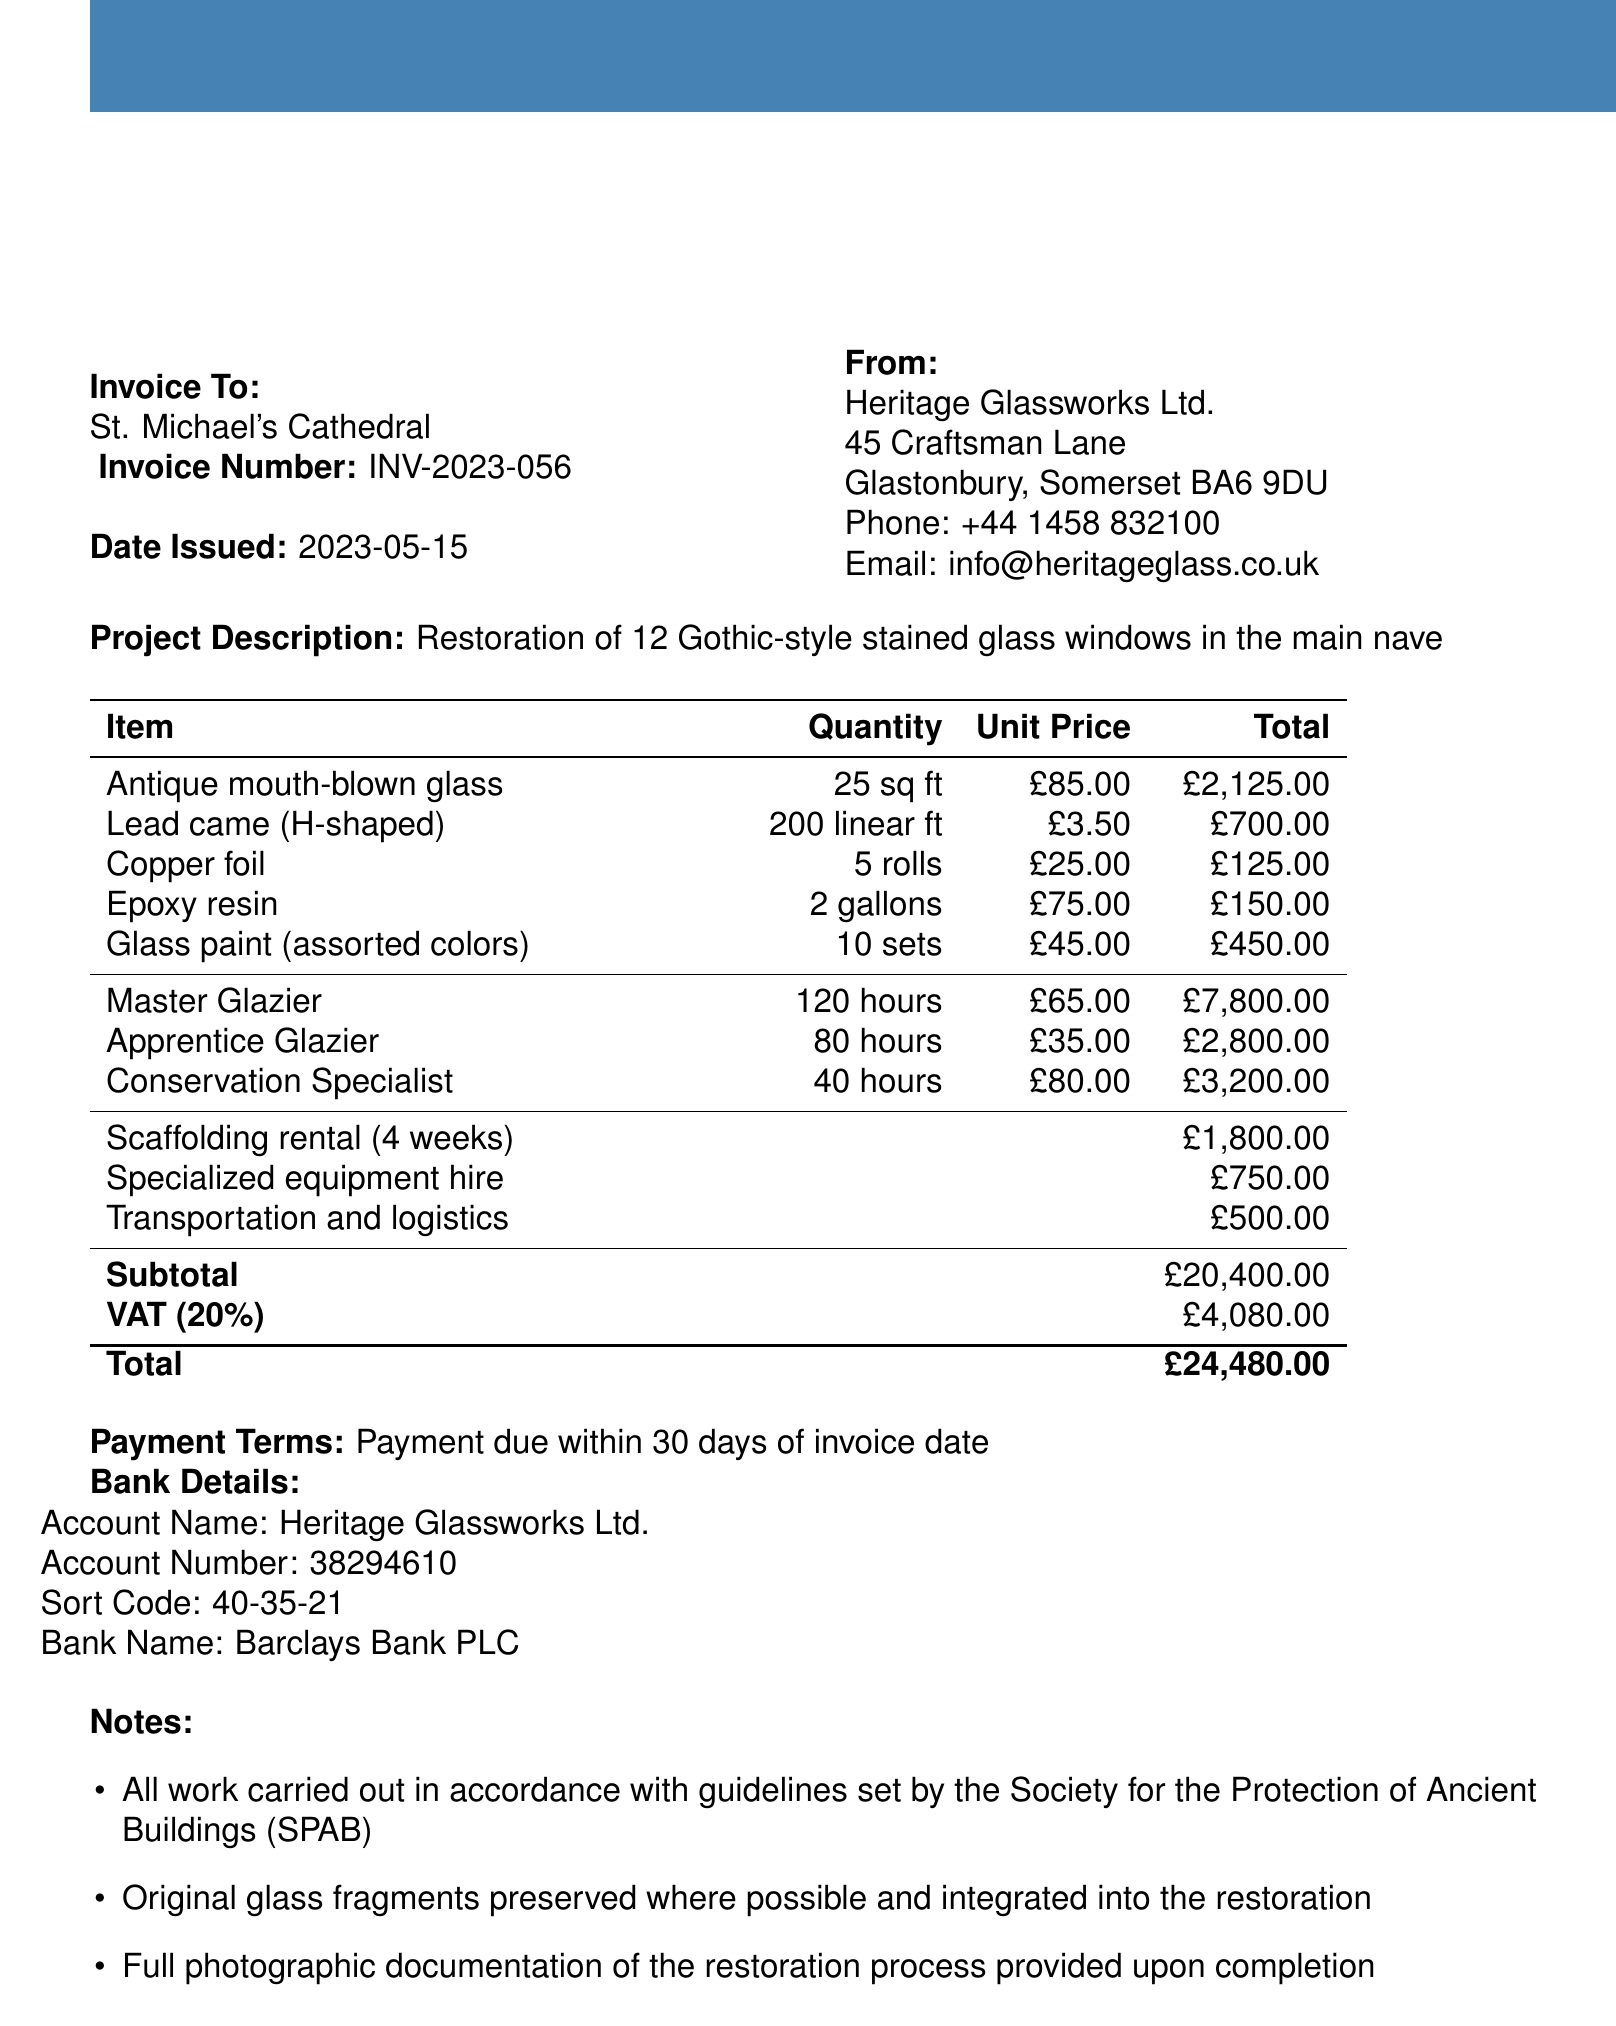What is the church name? The church name is stated in the document's header section.
Answer: St. Michael's Cathedral What is the invoice number? The invoice number is explicitly mentioned at the start of the document.
Answer: INV-2023-056 What is the date issued? The date issued is stated next to the invoice number in the document.
Answer: 2023-05-15 What is the total cost of materials? The total cost of materials can be calculated from the individual total prices listed in the materials section.
Answer: £3,100.00 How many hours did the Master Glazier work? The number of hours worked by the Master Glazier is provided in the labor costs section of the document.
Answer: 120 hours What is the total cost for labor? The total cost for labor is the sum of all labor costs listed in the document.
Answer: £13,800.00 What is the VAT amount? The VAT amount is clearly detailed in the document as part of the financial summary.
Answer: £4,080.00 What is the payment term? The payment terms are found in the financial section of the document.
Answer: Payment due within 30 days of invoice date What is included in the notes section? The notes section outlines specific guidelines and documentation related to the restoration work.
Answer: All work carried out in accordance with guidelines set by the Society for the Protection of Ancient Buildings (SPAB) 